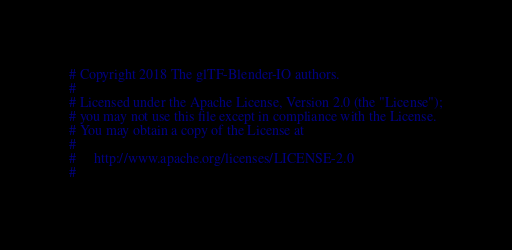<code> <loc_0><loc_0><loc_500><loc_500><_Python_># Copyright 2018 The glTF-Blender-IO authors.
#
# Licensed under the Apache License, Version 2.0 (the "License");
# you may not use this file except in compliance with the License.
# You may obtain a copy of the License at
#
#     http://www.apache.org/licenses/LICENSE-2.0
#</code> 